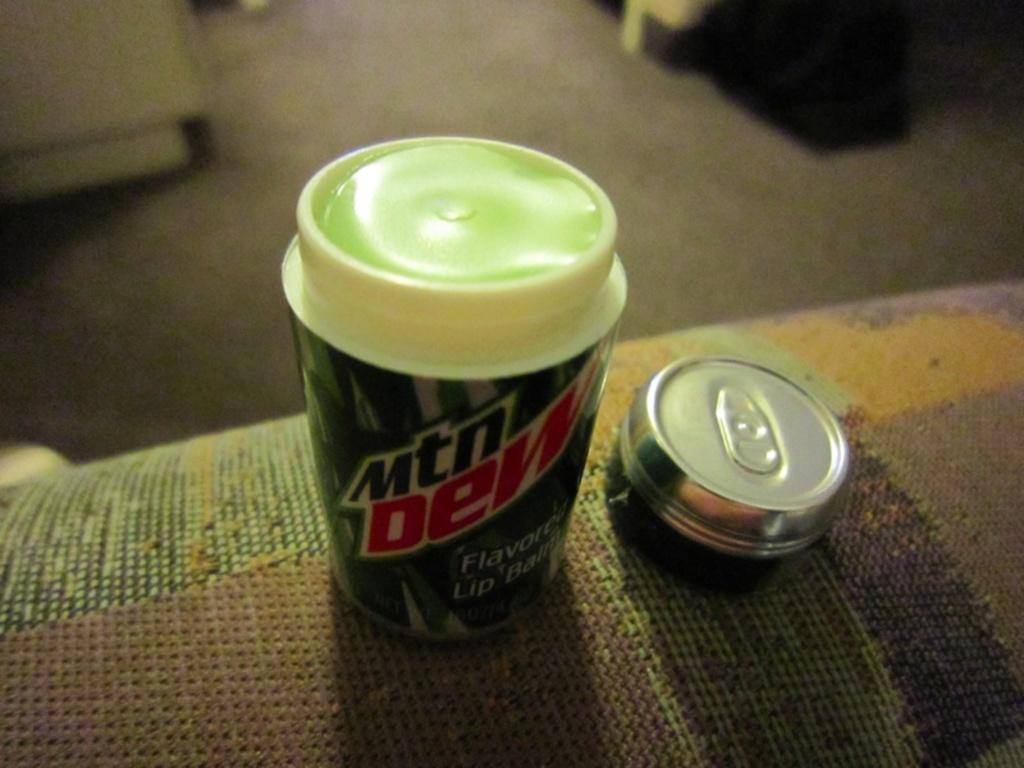Provide a one-sentence caption for the provided image. The lid of the Mtn Dew lip balm has been taken off. 